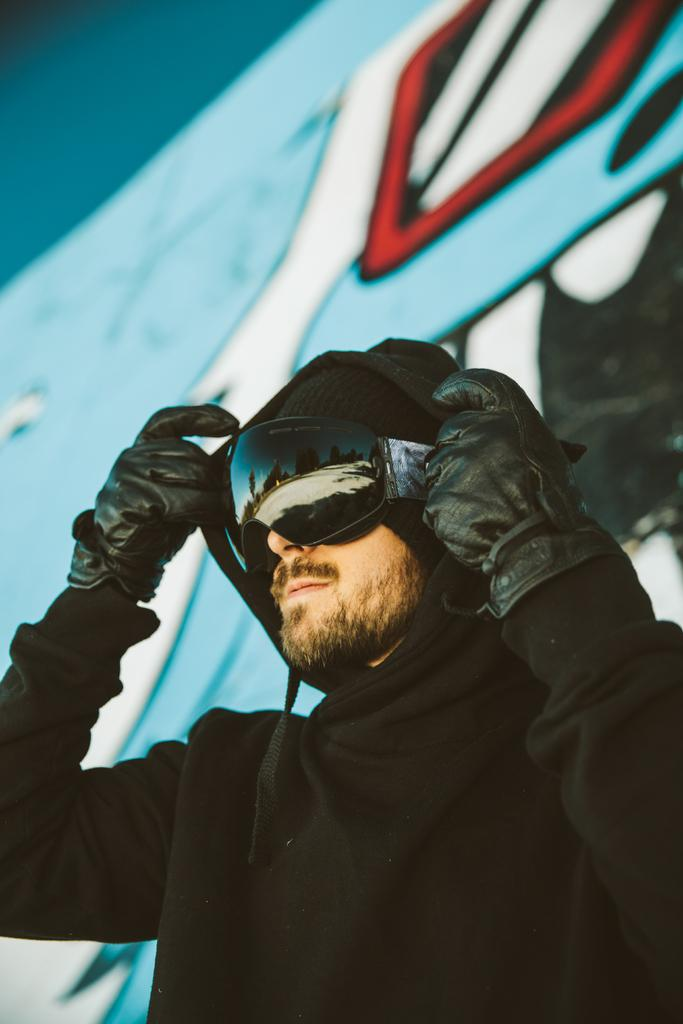What is the main subject of the image? There is a person in the image. What protective gear is the person wearing? The person is wearing goggles and gloves. What can be seen in the background of the image? There is a broad in the background of the image. What type of bells can be heard ringing in the image? There are no bells present in the image, and therefore no sound can be heard. How many rabbits are visible in the image? There are no rabbits present in the image. 